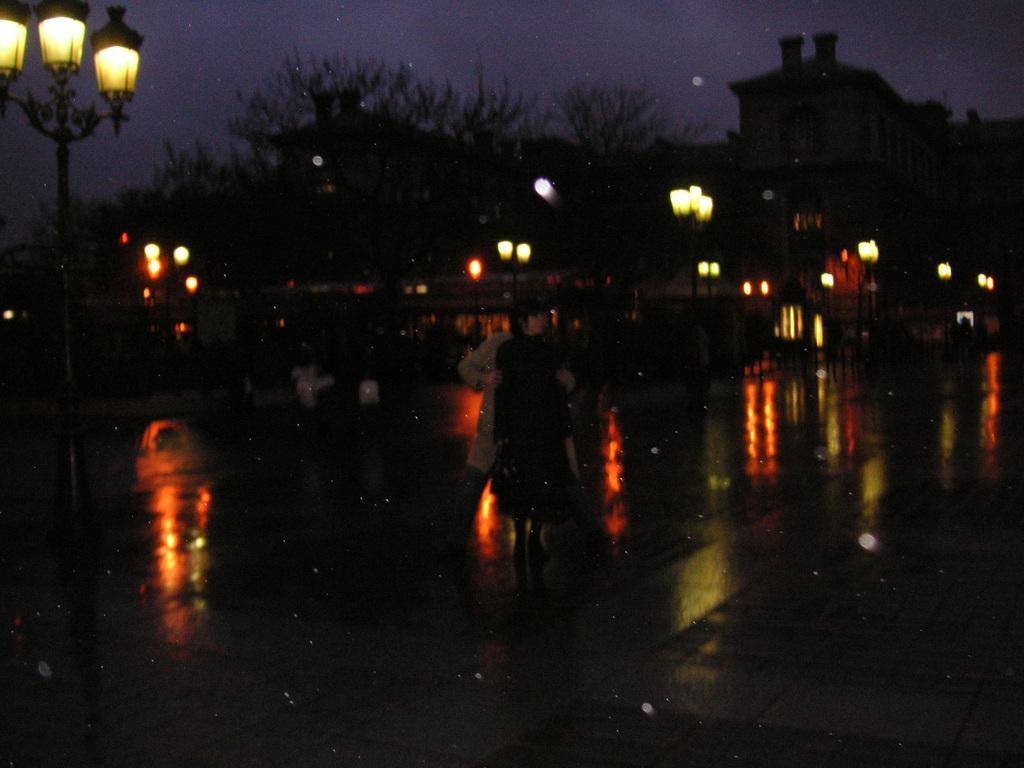Describe this image in one or two sentences. This image is clicked on the road. There are a few people walking on the road. There are street light poles, buildings and trees in the image. At the top there is the sky. The image is dark. 